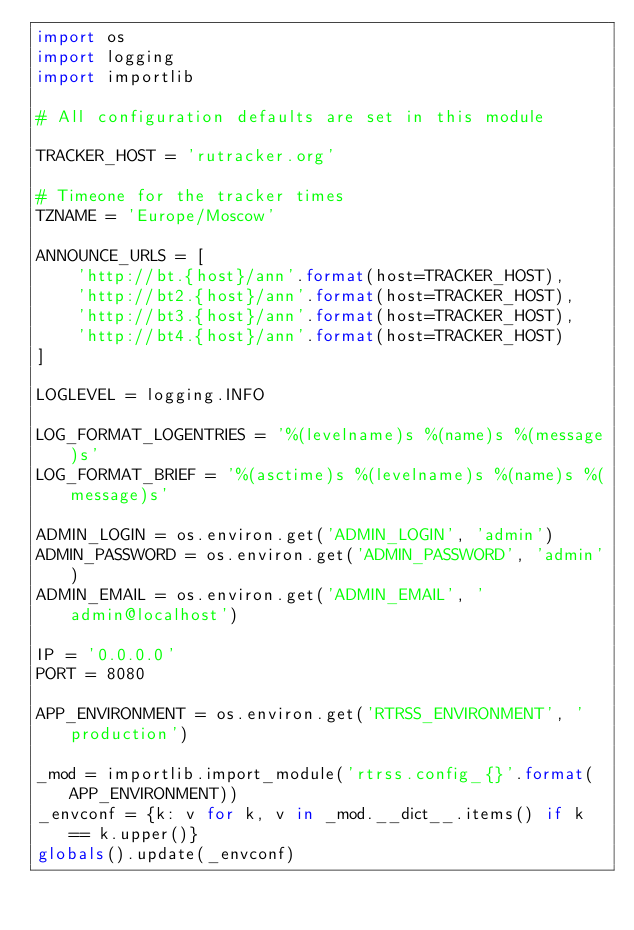<code> <loc_0><loc_0><loc_500><loc_500><_Python_>import os
import logging
import importlib

# All configuration defaults are set in this module

TRACKER_HOST = 'rutracker.org'

# Timeone for the tracker times
TZNAME = 'Europe/Moscow'

ANNOUNCE_URLS = [
    'http://bt.{host}/ann'.format(host=TRACKER_HOST),
    'http://bt2.{host}/ann'.format(host=TRACKER_HOST),
    'http://bt3.{host}/ann'.format(host=TRACKER_HOST),
    'http://bt4.{host}/ann'.format(host=TRACKER_HOST)
]

LOGLEVEL = logging.INFO

LOG_FORMAT_LOGENTRIES = '%(levelname)s %(name)s %(message)s'
LOG_FORMAT_BRIEF = '%(asctime)s %(levelname)s %(name)s %(message)s'

ADMIN_LOGIN = os.environ.get('ADMIN_LOGIN', 'admin')
ADMIN_PASSWORD = os.environ.get('ADMIN_PASSWORD', 'admin')
ADMIN_EMAIL = os.environ.get('ADMIN_EMAIL', 'admin@localhost')

IP = '0.0.0.0'
PORT = 8080

APP_ENVIRONMENT = os.environ.get('RTRSS_ENVIRONMENT', 'production')

_mod = importlib.import_module('rtrss.config_{}'.format(APP_ENVIRONMENT))
_envconf = {k: v for k, v in _mod.__dict__.items() if k == k.upper()}
globals().update(_envconf)
</code> 